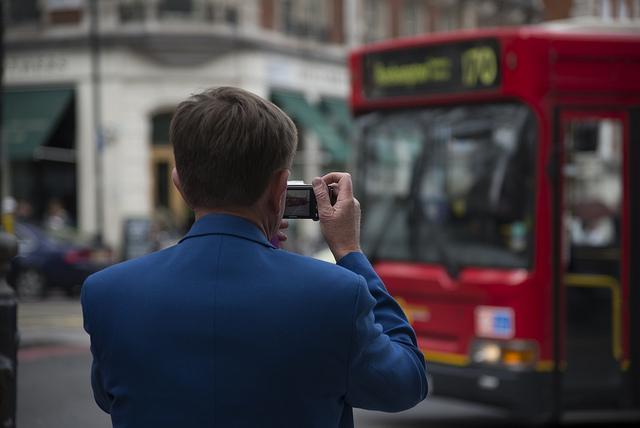How many sheep are here?
Give a very brief answer. 0. 